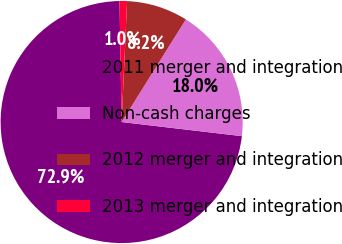<chart> <loc_0><loc_0><loc_500><loc_500><pie_chart><fcel>2011 merger and integration<fcel>Non-cash charges<fcel>2012 merger and integration<fcel>2013 merger and integration<nl><fcel>72.85%<fcel>17.96%<fcel>8.18%<fcel>1.0%<nl></chart> 